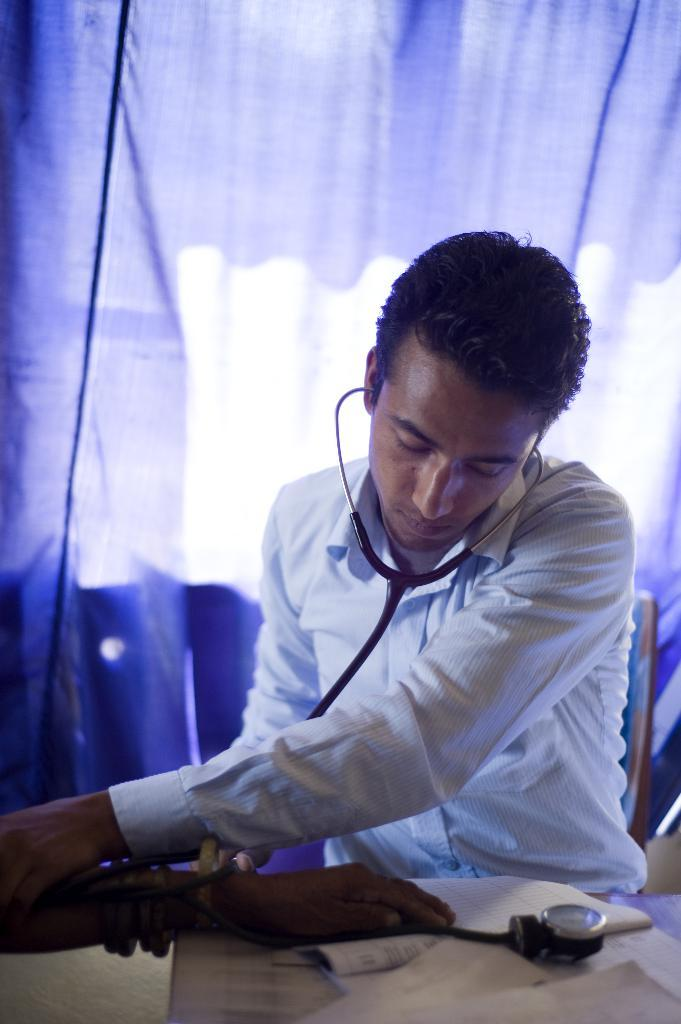What can be seen in the image? There is a person in the image. What is the person wearing? The person is wearing a white shirt. What is the person doing with their hand? The person is holding another person's hand. What object is the person holding? The person is holding a stethoscope. What can be seen in the background of the image? There is a cloth in the background of the image. What color is the cloth? The cloth is purple in color. What is the name of the button on the person's shirt? There is no button mentioned in the image, and the person's shirt is described as a white shirt, not a button-up shirt. 